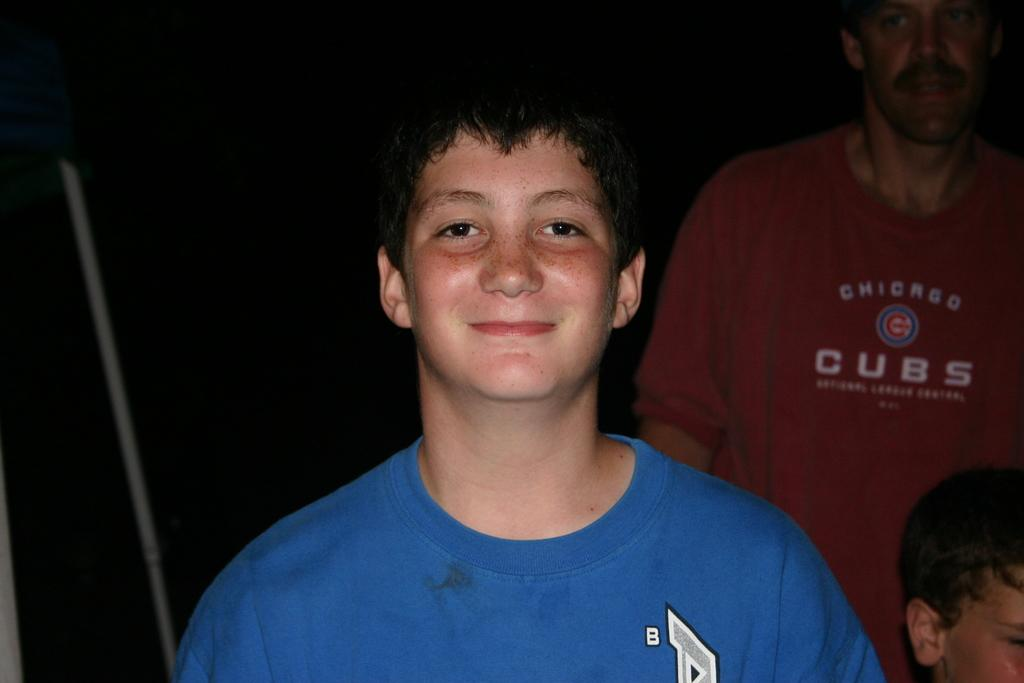What is the main subject of the image? There is a person standing and smiling in the center of the image. Can you describe the people in the background of the image? There are two persons in the background of the image. What else can be seen in the background of the image? There are a few other objects in the background of the image. What type of lawyer is present in the image? There is no lawyer present in the image. How does the person in the center of the image control their temper? The image does not provide information about the person's temper or how they control it. 